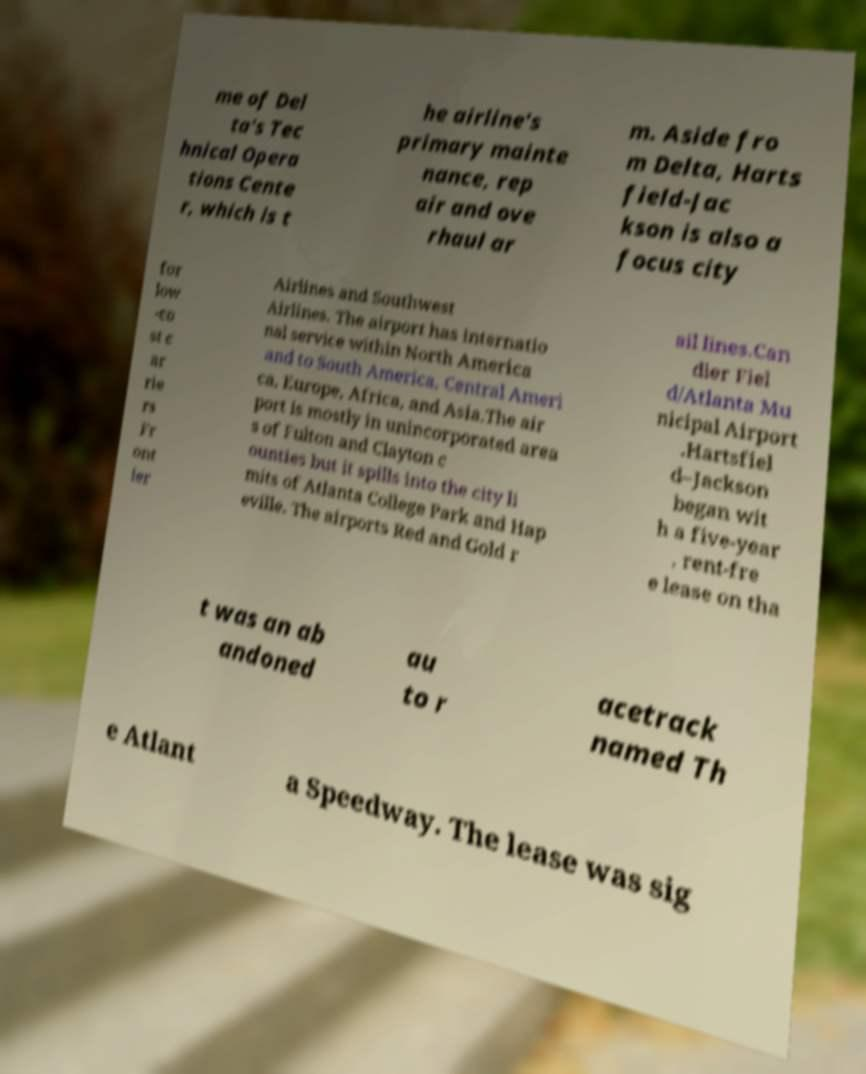Can you read and provide the text displayed in the image?This photo seems to have some interesting text. Can you extract and type it out for me? me of Del ta's Tec hnical Opera tions Cente r, which is t he airline's primary mainte nance, rep air and ove rhaul ar m. Aside fro m Delta, Harts field-Jac kson is also a focus city for low -co st c ar rie rs Fr ont ier Airlines and Southwest Airlines. The airport has internatio nal service within North America and to South America, Central Ameri ca, Europe, Africa, and Asia.The air port is mostly in unincorporated area s of Fulton and Clayton c ounties but it spills into the city li mits of Atlanta College Park and Hap eville. The airports Red and Gold r ail lines.Can dler Fiel d/Atlanta Mu nicipal Airport .Hartsfiel d–Jackson began wit h a five-year , rent-fre e lease on tha t was an ab andoned au to r acetrack named Th e Atlant a Speedway. The lease was sig 